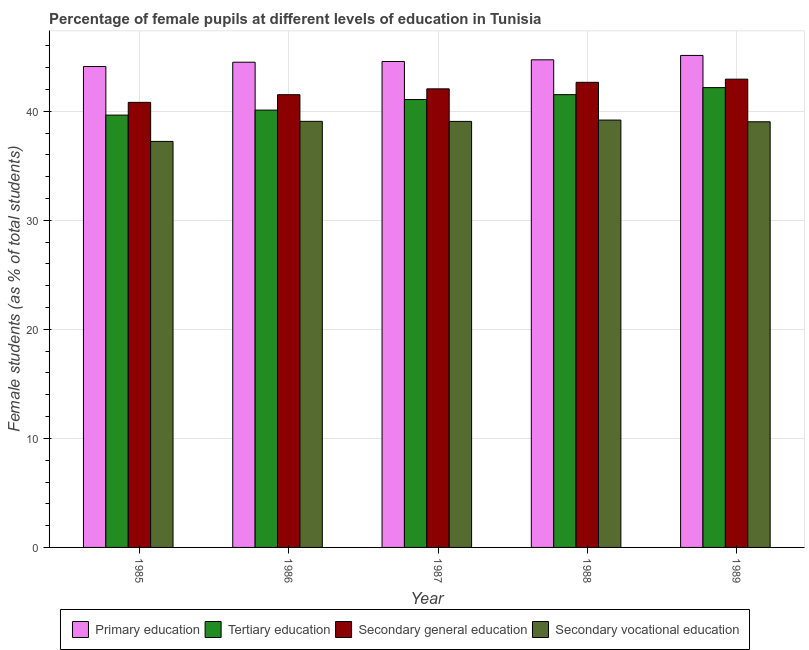Are the number of bars on each tick of the X-axis equal?
Your response must be concise. Yes. What is the percentage of female students in primary education in 1987?
Your response must be concise. 44.57. Across all years, what is the maximum percentage of female students in primary education?
Give a very brief answer. 45.13. Across all years, what is the minimum percentage of female students in primary education?
Provide a succinct answer. 44.11. In which year was the percentage of female students in tertiary education maximum?
Offer a terse response. 1989. In which year was the percentage of female students in secondary vocational education minimum?
Ensure brevity in your answer.  1985. What is the total percentage of female students in primary education in the graph?
Provide a short and direct response. 223.05. What is the difference between the percentage of female students in secondary vocational education in 1987 and that in 1988?
Your answer should be very brief. -0.12. What is the difference between the percentage of female students in primary education in 1985 and the percentage of female students in secondary education in 1988?
Ensure brevity in your answer.  -0.62. What is the average percentage of female students in secondary vocational education per year?
Your response must be concise. 38.73. In how many years, is the percentage of female students in primary education greater than 18 %?
Keep it short and to the point. 5. What is the ratio of the percentage of female students in tertiary education in 1986 to that in 1989?
Give a very brief answer. 0.95. Is the difference between the percentage of female students in secondary vocational education in 1986 and 1988 greater than the difference between the percentage of female students in tertiary education in 1986 and 1988?
Offer a very short reply. No. What is the difference between the highest and the second highest percentage of female students in secondary education?
Your answer should be very brief. 0.29. What is the difference between the highest and the lowest percentage of female students in primary education?
Your response must be concise. 1.02. In how many years, is the percentage of female students in primary education greater than the average percentage of female students in primary education taken over all years?
Keep it short and to the point. 2. Is the sum of the percentage of female students in tertiary education in 1986 and 1987 greater than the maximum percentage of female students in primary education across all years?
Provide a succinct answer. Yes. Is it the case that in every year, the sum of the percentage of female students in secondary education and percentage of female students in secondary vocational education is greater than the sum of percentage of female students in primary education and percentage of female students in tertiary education?
Keep it short and to the point. Yes. What does the 1st bar from the right in 1987 represents?
Your answer should be compact. Secondary vocational education. Where does the legend appear in the graph?
Your answer should be compact. Bottom center. How many legend labels are there?
Your response must be concise. 4. What is the title of the graph?
Provide a succinct answer. Percentage of female pupils at different levels of education in Tunisia. What is the label or title of the X-axis?
Your answer should be very brief. Year. What is the label or title of the Y-axis?
Provide a short and direct response. Female students (as % of total students). What is the Female students (as % of total students) of Primary education in 1985?
Ensure brevity in your answer.  44.11. What is the Female students (as % of total students) of Tertiary education in 1985?
Offer a very short reply. 39.66. What is the Female students (as % of total students) of Secondary general education in 1985?
Ensure brevity in your answer.  40.82. What is the Female students (as % of total students) in Secondary vocational education in 1985?
Provide a short and direct response. 37.24. What is the Female students (as % of total students) in Primary education in 1986?
Offer a very short reply. 44.51. What is the Female students (as % of total students) of Tertiary education in 1986?
Provide a succinct answer. 40.12. What is the Female students (as % of total students) of Secondary general education in 1986?
Offer a very short reply. 41.53. What is the Female students (as % of total students) in Secondary vocational education in 1986?
Make the answer very short. 39.08. What is the Female students (as % of total students) of Primary education in 1987?
Your answer should be very brief. 44.57. What is the Female students (as % of total students) of Tertiary education in 1987?
Offer a very short reply. 41.08. What is the Female students (as % of total students) in Secondary general education in 1987?
Make the answer very short. 42.06. What is the Female students (as % of total students) of Secondary vocational education in 1987?
Ensure brevity in your answer.  39.08. What is the Female students (as % of total students) in Primary education in 1988?
Provide a succinct answer. 44.73. What is the Female students (as % of total students) in Tertiary education in 1988?
Keep it short and to the point. 41.53. What is the Female students (as % of total students) of Secondary general education in 1988?
Your answer should be very brief. 42.66. What is the Female students (as % of total students) in Secondary vocational education in 1988?
Your response must be concise. 39.2. What is the Female students (as % of total students) of Primary education in 1989?
Provide a succinct answer. 45.13. What is the Female students (as % of total students) of Tertiary education in 1989?
Offer a terse response. 42.18. What is the Female students (as % of total students) in Secondary general education in 1989?
Provide a short and direct response. 42.95. What is the Female students (as % of total students) of Secondary vocational education in 1989?
Provide a succinct answer. 39.05. Across all years, what is the maximum Female students (as % of total students) in Primary education?
Ensure brevity in your answer.  45.13. Across all years, what is the maximum Female students (as % of total students) of Tertiary education?
Provide a succinct answer. 42.18. Across all years, what is the maximum Female students (as % of total students) of Secondary general education?
Ensure brevity in your answer.  42.95. Across all years, what is the maximum Female students (as % of total students) of Secondary vocational education?
Give a very brief answer. 39.2. Across all years, what is the minimum Female students (as % of total students) of Primary education?
Provide a succinct answer. 44.11. Across all years, what is the minimum Female students (as % of total students) in Tertiary education?
Provide a succinct answer. 39.66. Across all years, what is the minimum Female students (as % of total students) in Secondary general education?
Your answer should be very brief. 40.82. Across all years, what is the minimum Female students (as % of total students) in Secondary vocational education?
Provide a short and direct response. 37.24. What is the total Female students (as % of total students) in Primary education in the graph?
Keep it short and to the point. 223.05. What is the total Female students (as % of total students) of Tertiary education in the graph?
Provide a succinct answer. 204.57. What is the total Female students (as % of total students) in Secondary general education in the graph?
Provide a short and direct response. 210.03. What is the total Female students (as % of total students) of Secondary vocational education in the graph?
Make the answer very short. 193.65. What is the difference between the Female students (as % of total students) of Primary education in 1985 and that in 1986?
Offer a very short reply. -0.4. What is the difference between the Female students (as % of total students) of Tertiary education in 1985 and that in 1986?
Your response must be concise. -0.46. What is the difference between the Female students (as % of total students) in Secondary general education in 1985 and that in 1986?
Offer a very short reply. -0.7. What is the difference between the Female students (as % of total students) of Secondary vocational education in 1985 and that in 1986?
Offer a terse response. -1.84. What is the difference between the Female students (as % of total students) of Primary education in 1985 and that in 1987?
Your answer should be compact. -0.46. What is the difference between the Female students (as % of total students) in Tertiary education in 1985 and that in 1987?
Provide a short and direct response. -1.43. What is the difference between the Female students (as % of total students) of Secondary general education in 1985 and that in 1987?
Ensure brevity in your answer.  -1.24. What is the difference between the Female students (as % of total students) of Secondary vocational education in 1985 and that in 1987?
Provide a short and direct response. -1.84. What is the difference between the Female students (as % of total students) of Primary education in 1985 and that in 1988?
Ensure brevity in your answer.  -0.62. What is the difference between the Female students (as % of total students) of Tertiary education in 1985 and that in 1988?
Provide a succinct answer. -1.88. What is the difference between the Female students (as % of total students) of Secondary general education in 1985 and that in 1988?
Offer a terse response. -1.84. What is the difference between the Female students (as % of total students) in Secondary vocational education in 1985 and that in 1988?
Give a very brief answer. -1.96. What is the difference between the Female students (as % of total students) of Primary education in 1985 and that in 1989?
Your answer should be very brief. -1.02. What is the difference between the Female students (as % of total students) of Tertiary education in 1985 and that in 1989?
Offer a terse response. -2.52. What is the difference between the Female students (as % of total students) in Secondary general education in 1985 and that in 1989?
Keep it short and to the point. -2.13. What is the difference between the Female students (as % of total students) in Secondary vocational education in 1985 and that in 1989?
Your answer should be very brief. -1.8. What is the difference between the Female students (as % of total students) of Primary education in 1986 and that in 1987?
Make the answer very short. -0.07. What is the difference between the Female students (as % of total students) in Tertiary education in 1986 and that in 1987?
Ensure brevity in your answer.  -0.97. What is the difference between the Female students (as % of total students) of Secondary general education in 1986 and that in 1987?
Offer a very short reply. -0.54. What is the difference between the Female students (as % of total students) of Secondary vocational education in 1986 and that in 1987?
Your answer should be compact. 0.01. What is the difference between the Female students (as % of total students) in Primary education in 1986 and that in 1988?
Provide a succinct answer. -0.22. What is the difference between the Female students (as % of total students) of Tertiary education in 1986 and that in 1988?
Your answer should be compact. -1.42. What is the difference between the Female students (as % of total students) in Secondary general education in 1986 and that in 1988?
Keep it short and to the point. -1.13. What is the difference between the Female students (as % of total students) in Secondary vocational education in 1986 and that in 1988?
Keep it short and to the point. -0.12. What is the difference between the Female students (as % of total students) of Primary education in 1986 and that in 1989?
Offer a very short reply. -0.62. What is the difference between the Female students (as % of total students) of Tertiary education in 1986 and that in 1989?
Provide a short and direct response. -2.06. What is the difference between the Female students (as % of total students) of Secondary general education in 1986 and that in 1989?
Your answer should be very brief. -1.42. What is the difference between the Female students (as % of total students) of Secondary vocational education in 1986 and that in 1989?
Your answer should be very brief. 0.04. What is the difference between the Female students (as % of total students) of Primary education in 1987 and that in 1988?
Provide a succinct answer. -0.15. What is the difference between the Female students (as % of total students) of Tertiary education in 1987 and that in 1988?
Offer a terse response. -0.45. What is the difference between the Female students (as % of total students) of Secondary general education in 1987 and that in 1988?
Provide a short and direct response. -0.6. What is the difference between the Female students (as % of total students) in Secondary vocational education in 1987 and that in 1988?
Ensure brevity in your answer.  -0.12. What is the difference between the Female students (as % of total students) in Primary education in 1987 and that in 1989?
Your answer should be compact. -0.56. What is the difference between the Female students (as % of total students) of Tertiary education in 1987 and that in 1989?
Provide a short and direct response. -1.09. What is the difference between the Female students (as % of total students) of Secondary general education in 1987 and that in 1989?
Ensure brevity in your answer.  -0.89. What is the difference between the Female students (as % of total students) in Secondary vocational education in 1987 and that in 1989?
Give a very brief answer. 0.03. What is the difference between the Female students (as % of total students) of Primary education in 1988 and that in 1989?
Offer a terse response. -0.4. What is the difference between the Female students (as % of total students) of Tertiary education in 1988 and that in 1989?
Give a very brief answer. -0.64. What is the difference between the Female students (as % of total students) of Secondary general education in 1988 and that in 1989?
Offer a very short reply. -0.29. What is the difference between the Female students (as % of total students) of Secondary vocational education in 1988 and that in 1989?
Provide a succinct answer. 0.16. What is the difference between the Female students (as % of total students) of Primary education in 1985 and the Female students (as % of total students) of Tertiary education in 1986?
Provide a short and direct response. 4. What is the difference between the Female students (as % of total students) of Primary education in 1985 and the Female students (as % of total students) of Secondary general education in 1986?
Ensure brevity in your answer.  2.58. What is the difference between the Female students (as % of total students) in Primary education in 1985 and the Female students (as % of total students) in Secondary vocational education in 1986?
Keep it short and to the point. 5.03. What is the difference between the Female students (as % of total students) in Tertiary education in 1985 and the Female students (as % of total students) in Secondary general education in 1986?
Ensure brevity in your answer.  -1.87. What is the difference between the Female students (as % of total students) in Tertiary education in 1985 and the Female students (as % of total students) in Secondary vocational education in 1986?
Keep it short and to the point. 0.57. What is the difference between the Female students (as % of total students) of Secondary general education in 1985 and the Female students (as % of total students) of Secondary vocational education in 1986?
Your answer should be compact. 1.74. What is the difference between the Female students (as % of total students) of Primary education in 1985 and the Female students (as % of total students) of Tertiary education in 1987?
Provide a succinct answer. 3.03. What is the difference between the Female students (as % of total students) in Primary education in 1985 and the Female students (as % of total students) in Secondary general education in 1987?
Provide a short and direct response. 2.05. What is the difference between the Female students (as % of total students) in Primary education in 1985 and the Female students (as % of total students) in Secondary vocational education in 1987?
Your answer should be very brief. 5.03. What is the difference between the Female students (as % of total students) in Tertiary education in 1985 and the Female students (as % of total students) in Secondary general education in 1987?
Your response must be concise. -2.41. What is the difference between the Female students (as % of total students) in Tertiary education in 1985 and the Female students (as % of total students) in Secondary vocational education in 1987?
Your answer should be compact. 0.58. What is the difference between the Female students (as % of total students) of Secondary general education in 1985 and the Female students (as % of total students) of Secondary vocational education in 1987?
Provide a short and direct response. 1.75. What is the difference between the Female students (as % of total students) of Primary education in 1985 and the Female students (as % of total students) of Tertiary education in 1988?
Make the answer very short. 2.58. What is the difference between the Female students (as % of total students) in Primary education in 1985 and the Female students (as % of total students) in Secondary general education in 1988?
Keep it short and to the point. 1.45. What is the difference between the Female students (as % of total students) in Primary education in 1985 and the Female students (as % of total students) in Secondary vocational education in 1988?
Provide a succinct answer. 4.91. What is the difference between the Female students (as % of total students) of Tertiary education in 1985 and the Female students (as % of total students) of Secondary general education in 1988?
Provide a short and direct response. -3.01. What is the difference between the Female students (as % of total students) of Tertiary education in 1985 and the Female students (as % of total students) of Secondary vocational education in 1988?
Offer a terse response. 0.45. What is the difference between the Female students (as % of total students) in Secondary general education in 1985 and the Female students (as % of total students) in Secondary vocational education in 1988?
Your response must be concise. 1.62. What is the difference between the Female students (as % of total students) of Primary education in 1985 and the Female students (as % of total students) of Tertiary education in 1989?
Your response must be concise. 1.93. What is the difference between the Female students (as % of total students) of Primary education in 1985 and the Female students (as % of total students) of Secondary general education in 1989?
Ensure brevity in your answer.  1.16. What is the difference between the Female students (as % of total students) of Primary education in 1985 and the Female students (as % of total students) of Secondary vocational education in 1989?
Provide a short and direct response. 5.07. What is the difference between the Female students (as % of total students) of Tertiary education in 1985 and the Female students (as % of total students) of Secondary general education in 1989?
Offer a terse response. -3.3. What is the difference between the Female students (as % of total students) of Tertiary education in 1985 and the Female students (as % of total students) of Secondary vocational education in 1989?
Offer a terse response. 0.61. What is the difference between the Female students (as % of total students) of Secondary general education in 1985 and the Female students (as % of total students) of Secondary vocational education in 1989?
Ensure brevity in your answer.  1.78. What is the difference between the Female students (as % of total students) in Primary education in 1986 and the Female students (as % of total students) in Tertiary education in 1987?
Provide a short and direct response. 3.42. What is the difference between the Female students (as % of total students) of Primary education in 1986 and the Female students (as % of total students) of Secondary general education in 1987?
Provide a succinct answer. 2.44. What is the difference between the Female students (as % of total students) of Primary education in 1986 and the Female students (as % of total students) of Secondary vocational education in 1987?
Offer a very short reply. 5.43. What is the difference between the Female students (as % of total students) of Tertiary education in 1986 and the Female students (as % of total students) of Secondary general education in 1987?
Make the answer very short. -1.95. What is the difference between the Female students (as % of total students) of Tertiary education in 1986 and the Female students (as % of total students) of Secondary vocational education in 1987?
Offer a terse response. 1.04. What is the difference between the Female students (as % of total students) in Secondary general education in 1986 and the Female students (as % of total students) in Secondary vocational education in 1987?
Ensure brevity in your answer.  2.45. What is the difference between the Female students (as % of total students) of Primary education in 1986 and the Female students (as % of total students) of Tertiary education in 1988?
Make the answer very short. 2.97. What is the difference between the Female students (as % of total students) in Primary education in 1986 and the Female students (as % of total students) in Secondary general education in 1988?
Your answer should be very brief. 1.84. What is the difference between the Female students (as % of total students) in Primary education in 1986 and the Female students (as % of total students) in Secondary vocational education in 1988?
Make the answer very short. 5.31. What is the difference between the Female students (as % of total students) of Tertiary education in 1986 and the Female students (as % of total students) of Secondary general education in 1988?
Keep it short and to the point. -2.55. What is the difference between the Female students (as % of total students) in Tertiary education in 1986 and the Female students (as % of total students) in Secondary vocational education in 1988?
Offer a terse response. 0.91. What is the difference between the Female students (as % of total students) of Secondary general education in 1986 and the Female students (as % of total students) of Secondary vocational education in 1988?
Make the answer very short. 2.33. What is the difference between the Female students (as % of total students) of Primary education in 1986 and the Female students (as % of total students) of Tertiary education in 1989?
Offer a terse response. 2.33. What is the difference between the Female students (as % of total students) in Primary education in 1986 and the Female students (as % of total students) in Secondary general education in 1989?
Your response must be concise. 1.56. What is the difference between the Female students (as % of total students) of Primary education in 1986 and the Female students (as % of total students) of Secondary vocational education in 1989?
Provide a succinct answer. 5.46. What is the difference between the Female students (as % of total students) of Tertiary education in 1986 and the Female students (as % of total students) of Secondary general education in 1989?
Provide a succinct answer. -2.84. What is the difference between the Female students (as % of total students) of Tertiary education in 1986 and the Female students (as % of total students) of Secondary vocational education in 1989?
Your answer should be compact. 1.07. What is the difference between the Female students (as % of total students) in Secondary general education in 1986 and the Female students (as % of total students) in Secondary vocational education in 1989?
Offer a very short reply. 2.48. What is the difference between the Female students (as % of total students) of Primary education in 1987 and the Female students (as % of total students) of Tertiary education in 1988?
Offer a very short reply. 3.04. What is the difference between the Female students (as % of total students) in Primary education in 1987 and the Female students (as % of total students) in Secondary general education in 1988?
Give a very brief answer. 1.91. What is the difference between the Female students (as % of total students) in Primary education in 1987 and the Female students (as % of total students) in Secondary vocational education in 1988?
Make the answer very short. 5.37. What is the difference between the Female students (as % of total students) of Tertiary education in 1987 and the Female students (as % of total students) of Secondary general education in 1988?
Ensure brevity in your answer.  -1.58. What is the difference between the Female students (as % of total students) of Tertiary education in 1987 and the Female students (as % of total students) of Secondary vocational education in 1988?
Provide a short and direct response. 1.88. What is the difference between the Female students (as % of total students) of Secondary general education in 1987 and the Female students (as % of total students) of Secondary vocational education in 1988?
Your response must be concise. 2.86. What is the difference between the Female students (as % of total students) in Primary education in 1987 and the Female students (as % of total students) in Tertiary education in 1989?
Provide a succinct answer. 2.4. What is the difference between the Female students (as % of total students) in Primary education in 1987 and the Female students (as % of total students) in Secondary general education in 1989?
Offer a very short reply. 1.62. What is the difference between the Female students (as % of total students) of Primary education in 1987 and the Female students (as % of total students) of Secondary vocational education in 1989?
Provide a succinct answer. 5.53. What is the difference between the Female students (as % of total students) in Tertiary education in 1987 and the Female students (as % of total students) in Secondary general education in 1989?
Your answer should be very brief. -1.87. What is the difference between the Female students (as % of total students) of Tertiary education in 1987 and the Female students (as % of total students) of Secondary vocational education in 1989?
Provide a succinct answer. 2.04. What is the difference between the Female students (as % of total students) in Secondary general education in 1987 and the Female students (as % of total students) in Secondary vocational education in 1989?
Make the answer very short. 3.02. What is the difference between the Female students (as % of total students) in Primary education in 1988 and the Female students (as % of total students) in Tertiary education in 1989?
Your answer should be compact. 2.55. What is the difference between the Female students (as % of total students) in Primary education in 1988 and the Female students (as % of total students) in Secondary general education in 1989?
Offer a terse response. 1.77. What is the difference between the Female students (as % of total students) of Primary education in 1988 and the Female students (as % of total students) of Secondary vocational education in 1989?
Make the answer very short. 5.68. What is the difference between the Female students (as % of total students) of Tertiary education in 1988 and the Female students (as % of total students) of Secondary general education in 1989?
Keep it short and to the point. -1.42. What is the difference between the Female students (as % of total students) in Tertiary education in 1988 and the Female students (as % of total students) in Secondary vocational education in 1989?
Make the answer very short. 2.49. What is the difference between the Female students (as % of total students) of Secondary general education in 1988 and the Female students (as % of total students) of Secondary vocational education in 1989?
Provide a succinct answer. 3.62. What is the average Female students (as % of total students) of Primary education per year?
Provide a short and direct response. 44.61. What is the average Female students (as % of total students) in Tertiary education per year?
Ensure brevity in your answer.  40.91. What is the average Female students (as % of total students) in Secondary general education per year?
Ensure brevity in your answer.  42.01. What is the average Female students (as % of total students) in Secondary vocational education per year?
Provide a succinct answer. 38.73. In the year 1985, what is the difference between the Female students (as % of total students) in Primary education and Female students (as % of total students) in Tertiary education?
Ensure brevity in your answer.  4.46. In the year 1985, what is the difference between the Female students (as % of total students) of Primary education and Female students (as % of total students) of Secondary general education?
Provide a short and direct response. 3.29. In the year 1985, what is the difference between the Female students (as % of total students) of Primary education and Female students (as % of total students) of Secondary vocational education?
Your answer should be very brief. 6.87. In the year 1985, what is the difference between the Female students (as % of total students) in Tertiary education and Female students (as % of total students) in Secondary general education?
Make the answer very short. -1.17. In the year 1985, what is the difference between the Female students (as % of total students) in Tertiary education and Female students (as % of total students) in Secondary vocational education?
Ensure brevity in your answer.  2.41. In the year 1985, what is the difference between the Female students (as % of total students) in Secondary general education and Female students (as % of total students) in Secondary vocational education?
Your answer should be very brief. 3.58. In the year 1986, what is the difference between the Female students (as % of total students) of Primary education and Female students (as % of total students) of Tertiary education?
Give a very brief answer. 4.39. In the year 1986, what is the difference between the Female students (as % of total students) in Primary education and Female students (as % of total students) in Secondary general education?
Provide a short and direct response. 2.98. In the year 1986, what is the difference between the Female students (as % of total students) in Primary education and Female students (as % of total students) in Secondary vocational education?
Keep it short and to the point. 5.42. In the year 1986, what is the difference between the Female students (as % of total students) in Tertiary education and Female students (as % of total students) in Secondary general education?
Your answer should be very brief. -1.41. In the year 1986, what is the difference between the Female students (as % of total students) in Tertiary education and Female students (as % of total students) in Secondary vocational education?
Keep it short and to the point. 1.03. In the year 1986, what is the difference between the Female students (as % of total students) of Secondary general education and Female students (as % of total students) of Secondary vocational education?
Make the answer very short. 2.44. In the year 1987, what is the difference between the Female students (as % of total students) of Primary education and Female students (as % of total students) of Tertiary education?
Provide a short and direct response. 3.49. In the year 1987, what is the difference between the Female students (as % of total students) in Primary education and Female students (as % of total students) in Secondary general education?
Your answer should be compact. 2.51. In the year 1987, what is the difference between the Female students (as % of total students) in Primary education and Female students (as % of total students) in Secondary vocational education?
Provide a succinct answer. 5.49. In the year 1987, what is the difference between the Female students (as % of total students) of Tertiary education and Female students (as % of total students) of Secondary general education?
Ensure brevity in your answer.  -0.98. In the year 1987, what is the difference between the Female students (as % of total students) of Tertiary education and Female students (as % of total students) of Secondary vocational education?
Ensure brevity in your answer.  2. In the year 1987, what is the difference between the Female students (as % of total students) of Secondary general education and Female students (as % of total students) of Secondary vocational education?
Provide a succinct answer. 2.99. In the year 1988, what is the difference between the Female students (as % of total students) in Primary education and Female students (as % of total students) in Tertiary education?
Your answer should be very brief. 3.19. In the year 1988, what is the difference between the Female students (as % of total students) of Primary education and Female students (as % of total students) of Secondary general education?
Your answer should be very brief. 2.06. In the year 1988, what is the difference between the Female students (as % of total students) of Primary education and Female students (as % of total students) of Secondary vocational education?
Ensure brevity in your answer.  5.53. In the year 1988, what is the difference between the Female students (as % of total students) in Tertiary education and Female students (as % of total students) in Secondary general education?
Your response must be concise. -1.13. In the year 1988, what is the difference between the Female students (as % of total students) in Tertiary education and Female students (as % of total students) in Secondary vocational education?
Ensure brevity in your answer.  2.33. In the year 1988, what is the difference between the Female students (as % of total students) of Secondary general education and Female students (as % of total students) of Secondary vocational education?
Your answer should be very brief. 3.46. In the year 1989, what is the difference between the Female students (as % of total students) in Primary education and Female students (as % of total students) in Tertiary education?
Your answer should be very brief. 2.95. In the year 1989, what is the difference between the Female students (as % of total students) of Primary education and Female students (as % of total students) of Secondary general education?
Your answer should be very brief. 2.18. In the year 1989, what is the difference between the Female students (as % of total students) in Primary education and Female students (as % of total students) in Secondary vocational education?
Make the answer very short. 6.09. In the year 1989, what is the difference between the Female students (as % of total students) of Tertiary education and Female students (as % of total students) of Secondary general education?
Keep it short and to the point. -0.77. In the year 1989, what is the difference between the Female students (as % of total students) in Tertiary education and Female students (as % of total students) in Secondary vocational education?
Your response must be concise. 3.13. In the year 1989, what is the difference between the Female students (as % of total students) of Secondary general education and Female students (as % of total students) of Secondary vocational education?
Provide a succinct answer. 3.91. What is the ratio of the Female students (as % of total students) of Primary education in 1985 to that in 1986?
Your answer should be compact. 0.99. What is the ratio of the Female students (as % of total students) of Tertiary education in 1985 to that in 1986?
Keep it short and to the point. 0.99. What is the ratio of the Female students (as % of total students) in Secondary general education in 1985 to that in 1986?
Offer a very short reply. 0.98. What is the ratio of the Female students (as % of total students) of Secondary vocational education in 1985 to that in 1986?
Give a very brief answer. 0.95. What is the ratio of the Female students (as % of total students) in Primary education in 1985 to that in 1987?
Your answer should be compact. 0.99. What is the ratio of the Female students (as % of total students) of Tertiary education in 1985 to that in 1987?
Provide a short and direct response. 0.97. What is the ratio of the Female students (as % of total students) of Secondary general education in 1985 to that in 1987?
Your answer should be very brief. 0.97. What is the ratio of the Female students (as % of total students) of Secondary vocational education in 1985 to that in 1987?
Provide a succinct answer. 0.95. What is the ratio of the Female students (as % of total students) in Primary education in 1985 to that in 1988?
Your answer should be compact. 0.99. What is the ratio of the Female students (as % of total students) in Tertiary education in 1985 to that in 1988?
Offer a terse response. 0.95. What is the ratio of the Female students (as % of total students) in Secondary general education in 1985 to that in 1988?
Your answer should be compact. 0.96. What is the ratio of the Female students (as % of total students) in Secondary vocational education in 1985 to that in 1988?
Ensure brevity in your answer.  0.95. What is the ratio of the Female students (as % of total students) in Primary education in 1985 to that in 1989?
Give a very brief answer. 0.98. What is the ratio of the Female students (as % of total students) of Tertiary education in 1985 to that in 1989?
Keep it short and to the point. 0.94. What is the ratio of the Female students (as % of total students) in Secondary general education in 1985 to that in 1989?
Your answer should be compact. 0.95. What is the ratio of the Female students (as % of total students) in Secondary vocational education in 1985 to that in 1989?
Your answer should be compact. 0.95. What is the ratio of the Female students (as % of total students) of Tertiary education in 1986 to that in 1987?
Give a very brief answer. 0.98. What is the ratio of the Female students (as % of total students) in Secondary general education in 1986 to that in 1987?
Your answer should be compact. 0.99. What is the ratio of the Female students (as % of total students) in Secondary vocational education in 1986 to that in 1987?
Your answer should be compact. 1. What is the ratio of the Female students (as % of total students) in Primary education in 1986 to that in 1988?
Your answer should be very brief. 1. What is the ratio of the Female students (as % of total students) in Tertiary education in 1986 to that in 1988?
Your answer should be compact. 0.97. What is the ratio of the Female students (as % of total students) in Secondary general education in 1986 to that in 1988?
Your answer should be compact. 0.97. What is the ratio of the Female students (as % of total students) of Secondary vocational education in 1986 to that in 1988?
Your response must be concise. 1. What is the ratio of the Female students (as % of total students) in Primary education in 1986 to that in 1989?
Provide a short and direct response. 0.99. What is the ratio of the Female students (as % of total students) of Tertiary education in 1986 to that in 1989?
Your answer should be compact. 0.95. What is the ratio of the Female students (as % of total students) of Secondary general education in 1986 to that in 1989?
Keep it short and to the point. 0.97. What is the ratio of the Female students (as % of total students) in Secondary vocational education in 1986 to that in 1989?
Keep it short and to the point. 1. What is the ratio of the Female students (as % of total students) in Primary education in 1987 to that in 1988?
Your response must be concise. 1. What is the ratio of the Female students (as % of total students) of Tertiary education in 1987 to that in 1988?
Your answer should be very brief. 0.99. What is the ratio of the Female students (as % of total students) in Secondary vocational education in 1987 to that in 1988?
Make the answer very short. 1. What is the ratio of the Female students (as % of total students) in Tertiary education in 1987 to that in 1989?
Ensure brevity in your answer.  0.97. What is the ratio of the Female students (as % of total students) of Secondary general education in 1987 to that in 1989?
Your answer should be compact. 0.98. What is the ratio of the Female students (as % of total students) of Secondary vocational education in 1987 to that in 1989?
Offer a very short reply. 1. What is the ratio of the Female students (as % of total students) of Primary education in 1988 to that in 1989?
Give a very brief answer. 0.99. What is the ratio of the Female students (as % of total students) in Tertiary education in 1988 to that in 1989?
Your response must be concise. 0.98. What is the ratio of the Female students (as % of total students) in Secondary general education in 1988 to that in 1989?
Your answer should be very brief. 0.99. What is the ratio of the Female students (as % of total students) in Secondary vocational education in 1988 to that in 1989?
Give a very brief answer. 1. What is the difference between the highest and the second highest Female students (as % of total students) of Primary education?
Your response must be concise. 0.4. What is the difference between the highest and the second highest Female students (as % of total students) of Tertiary education?
Your answer should be very brief. 0.64. What is the difference between the highest and the second highest Female students (as % of total students) in Secondary general education?
Make the answer very short. 0.29. What is the difference between the highest and the second highest Female students (as % of total students) in Secondary vocational education?
Your answer should be compact. 0.12. What is the difference between the highest and the lowest Female students (as % of total students) in Primary education?
Give a very brief answer. 1.02. What is the difference between the highest and the lowest Female students (as % of total students) of Tertiary education?
Offer a very short reply. 2.52. What is the difference between the highest and the lowest Female students (as % of total students) of Secondary general education?
Provide a succinct answer. 2.13. What is the difference between the highest and the lowest Female students (as % of total students) of Secondary vocational education?
Offer a terse response. 1.96. 